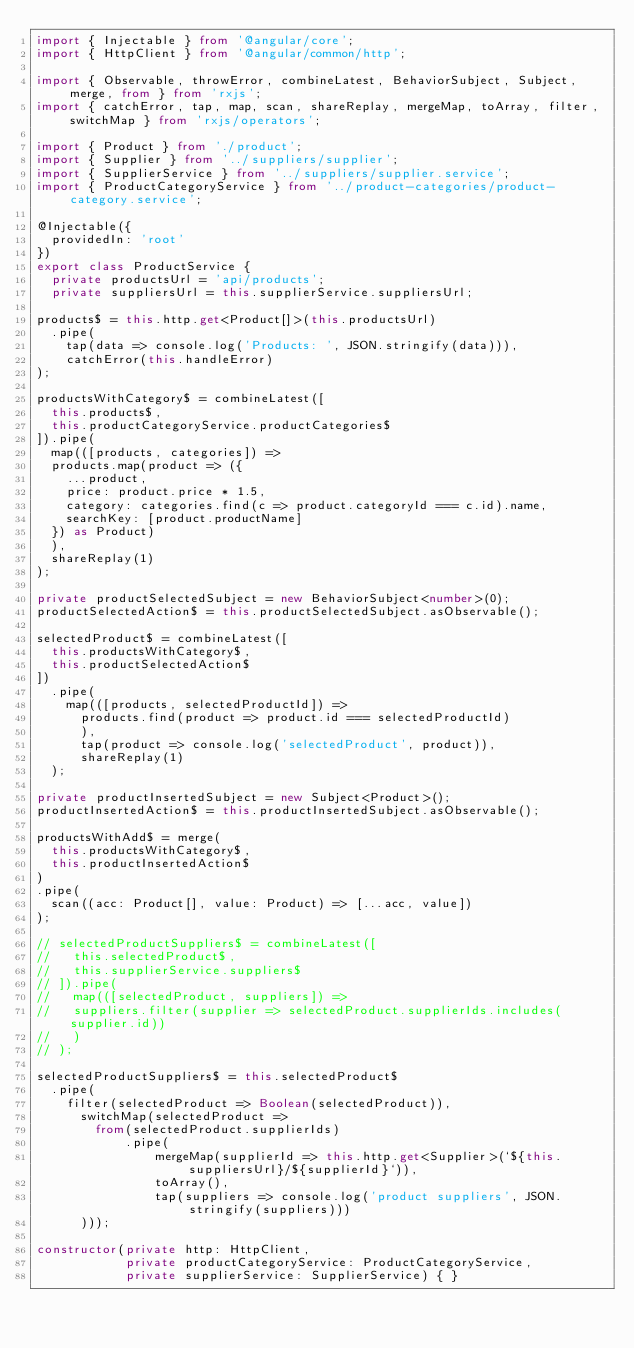Convert code to text. <code><loc_0><loc_0><loc_500><loc_500><_TypeScript_>import { Injectable } from '@angular/core';
import { HttpClient } from '@angular/common/http';

import { Observable, throwError, combineLatest, BehaviorSubject, Subject, merge, from } from 'rxjs';
import { catchError, tap, map, scan, shareReplay, mergeMap, toArray, filter, switchMap } from 'rxjs/operators';

import { Product } from './product';
import { Supplier } from '../suppliers/supplier';
import { SupplierService } from '../suppliers/supplier.service';
import { ProductCategoryService } from '../product-categories/product-category.service';

@Injectable({
  providedIn: 'root'
})
export class ProductService {
  private productsUrl = 'api/products';
  private suppliersUrl = this.supplierService.suppliersUrl;

products$ = this.http.get<Product[]>(this.productsUrl)
  .pipe(
    tap(data => console.log('Products: ', JSON.stringify(data))),
    catchError(this.handleError)
);

productsWithCategory$ = combineLatest([
  this.products$,
  this.productCategoryService.productCategories$
]).pipe(
  map(([products, categories]) =>
  products.map(product => ({
    ...product,
    price: product.price * 1.5,
    category: categories.find(c => product.categoryId === c.id).name,
    searchKey: [product.productName]
  }) as Product)
  ),
  shareReplay(1)
);

private productSelectedSubject = new BehaviorSubject<number>(0);
productSelectedAction$ = this.productSelectedSubject.asObservable();

selectedProduct$ = combineLatest([
  this.productsWithCategory$,
  this.productSelectedAction$
])
  .pipe(
    map(([products, selectedProductId]) =>
      products.find(product => product.id === selectedProductId)
      ),
      tap(product => console.log('selectedProduct', product)),
      shareReplay(1)
  );

private productInsertedSubject = new Subject<Product>();
productInsertedAction$ = this.productInsertedSubject.asObservable();

productsWithAdd$ = merge(
  this.productsWithCategory$,
  this.productInsertedAction$
)
.pipe(
  scan((acc: Product[], value: Product) => [...acc, value])
);

// selectedProductSuppliers$ = combineLatest([
//   this.selectedProduct$,
//   this.supplierService.suppliers$
// ]).pipe(
//   map(([selectedProduct, suppliers]) =>
//   suppliers.filter(supplier => selectedProduct.supplierIds.includes(supplier.id))
//   )
// );

selectedProductSuppliers$ = this.selectedProduct$
  .pipe(
    filter(selectedProduct => Boolean(selectedProduct)),
      switchMap(selectedProduct =>
        from(selectedProduct.supplierIds)
            .pipe(
                mergeMap(supplierId => this.http.get<Supplier>(`${this.suppliersUrl}/${supplierId}`)),
                toArray(),
                tap(suppliers => console.log('product suppliers', JSON.stringify(suppliers)))
      )));

constructor(private http: HttpClient,
            private productCategoryService: ProductCategoryService,
            private supplierService: SupplierService) { }
</code> 